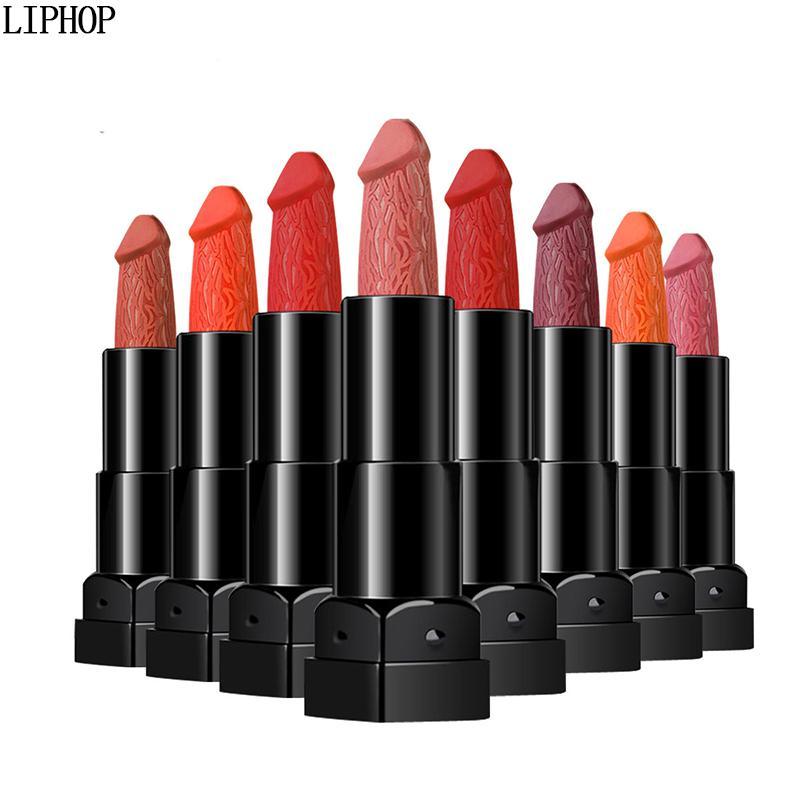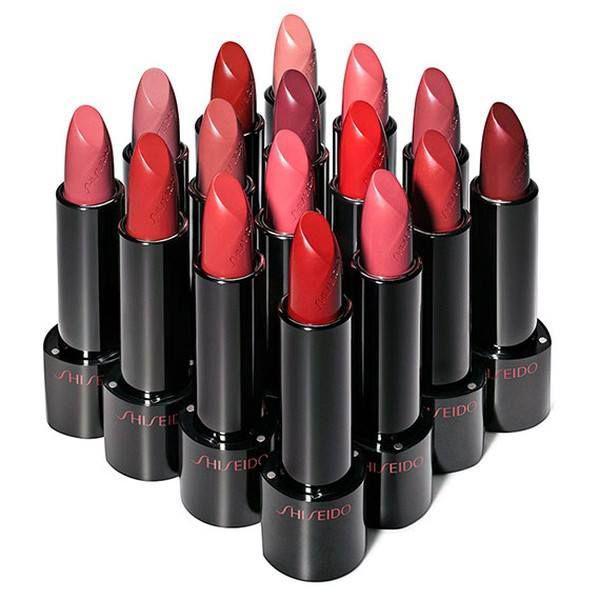The first image is the image on the left, the second image is the image on the right. Considering the images on both sides, is "There are exactly four lipsticks in the right image." valid? Answer yes or no. No. 